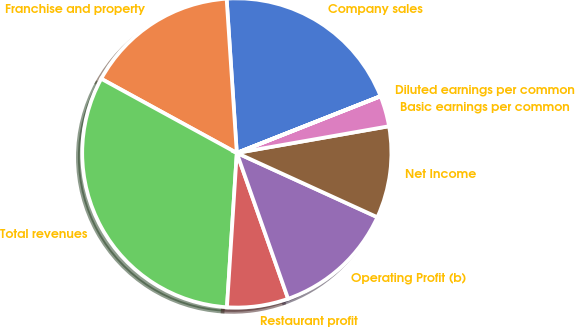<chart> <loc_0><loc_0><loc_500><loc_500><pie_chart><fcel>Company sales<fcel>Franchise and property<fcel>Total revenues<fcel>Restaurant profit<fcel>Operating Profit (b)<fcel>Net Income<fcel>Basic earnings per common<fcel>Diluted earnings per common<nl><fcel>20.06%<fcel>15.98%<fcel>31.95%<fcel>6.4%<fcel>12.79%<fcel>9.59%<fcel>3.21%<fcel>0.01%<nl></chart> 